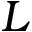Convert formula to latex. <formula><loc_0><loc_0><loc_500><loc_500>L</formula> 